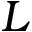Convert formula to latex. <formula><loc_0><loc_0><loc_500><loc_500>L</formula> 